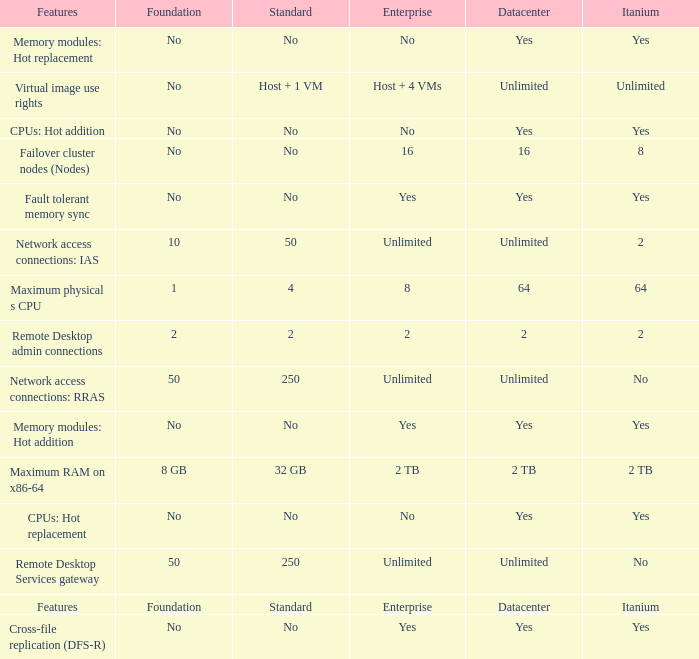Which Features have Yes listed under Datacenter? Cross-file replication (DFS-R), Fault tolerant memory sync, Memory modules: Hot addition, Memory modules: Hot replacement, CPUs: Hot addition, CPUs: Hot replacement. 